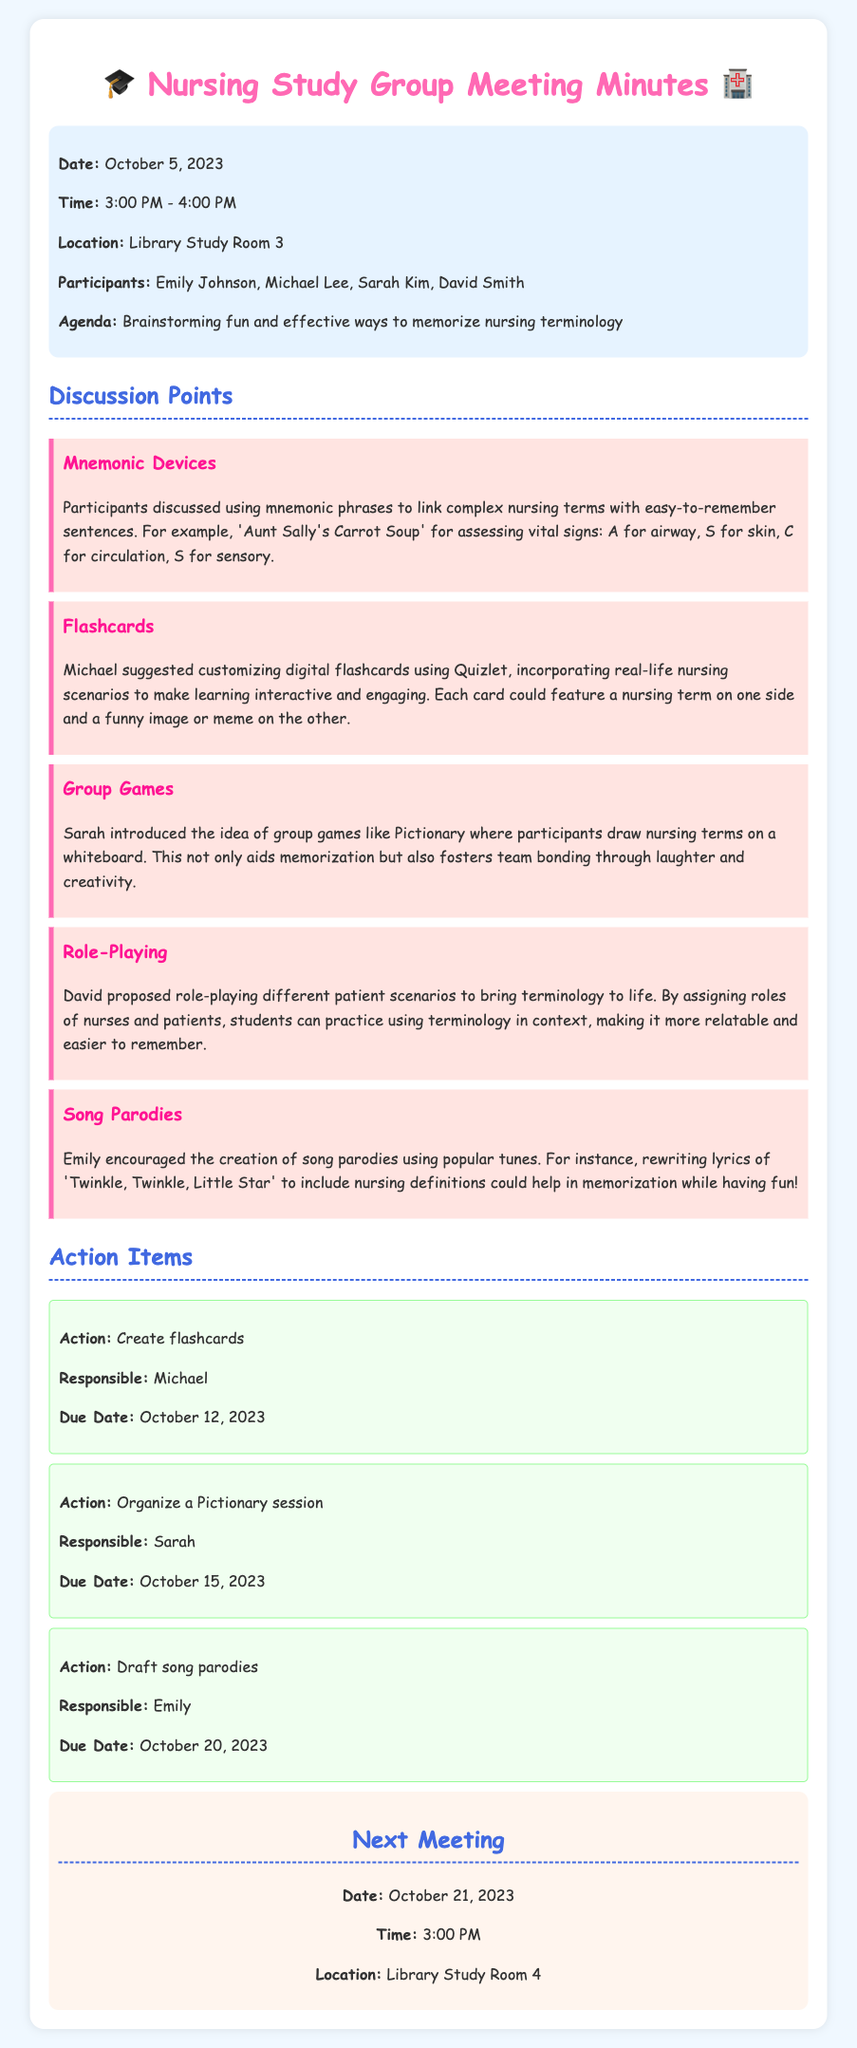What was the date of the meeting? The meeting took place on October 5, 2023.
Answer: October 5, 2023 Who proposed the idea of creating song parodies? Emily encouraged the creation of song parodies during the discussion.
Answer: Emily What is the due date for organizing the Pictionary session? Sarah is responsible for organizing the Pictionary session, which is due on October 15, 2023.
Answer: October 15, 2023 Which tool did Michael suggest for customizing flashcards? Michael suggested using Quizlet for creating customized digital flashcards.
Answer: Quizlet What is the next meeting date? The next meeting is scheduled for October 21, 2023.
Answer: October 21, 2023 How many participants attended the meeting? The document lists four participants: Emily Johnson, Michael Lee, Sarah Kim, and David Smith.
Answer: Four What technique was suggested for linking complex nursing terms? Participants discussed using mnemonic phrases to link complex nursing terms.
Answer: Mnemonic phrases What is the main purpose of the meeting? The agenda of the meeting was brainstorming fun and effective ways to memorize nursing terminology.
Answer: Memorize nursing terminology 